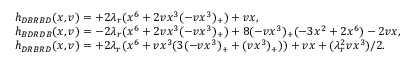<formula> <loc_0><loc_0><loc_500><loc_500>\begin{array} { r l } & { h _ { D B R B D } ( x , v ) = + 2 \lambda _ { r } ( x ^ { 6 } + 2 v x ^ { 3 } ( - v x ^ { 3 } ) _ { + } ) + v x , } \\ & { h _ { B D R D B } ( x , v ) = - 2 \lambda _ { r } ( x ^ { 6 } + 2 v x ^ { 3 } ( - v x ^ { 3 } ) _ { + } ) + 8 ( - v x ^ { 3 } ) _ { + } ( - 3 x ^ { 2 } + 2 x ^ { 6 } ) - 2 v x , } \\ & { h _ { D R B R D } ( x , v ) = + 2 \lambda _ { r } ( x ^ { 6 } + v x ^ { 3 } ( 3 ( - v x ^ { 3 } ) _ { + } + ( v x ^ { 3 } ) _ { + } ) ) + v x + ( \lambda _ { r } ^ { 2 } v x ^ { 3 } ) / 2 . } \end{array}</formula> 